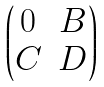Convert formula to latex. <formula><loc_0><loc_0><loc_500><loc_500>\begin{pmatrix} 0 & B \\ C & D \end{pmatrix}</formula> 